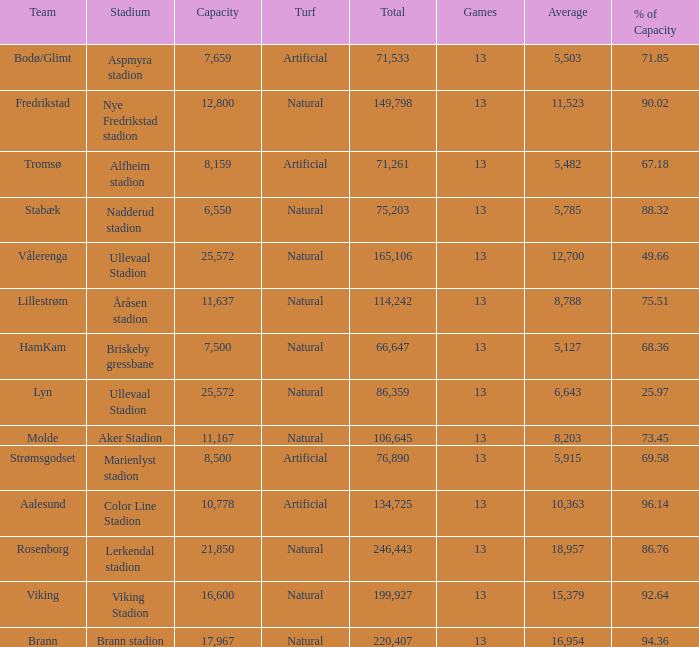What was the total attendance of aalesund which had a capacity with more than 96.14%? None. 